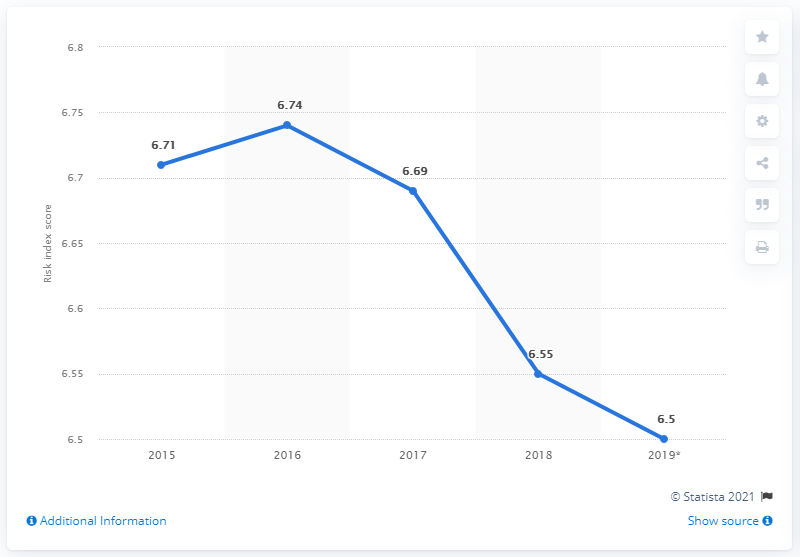List a handful of essential elements in this visual. Argentina's risk index began to trend downward in 2016. The risk index score for money laundering and terrorist financing in Argentina in 2018 was 6.55. The median value of all the points in the graph is 6.69. 